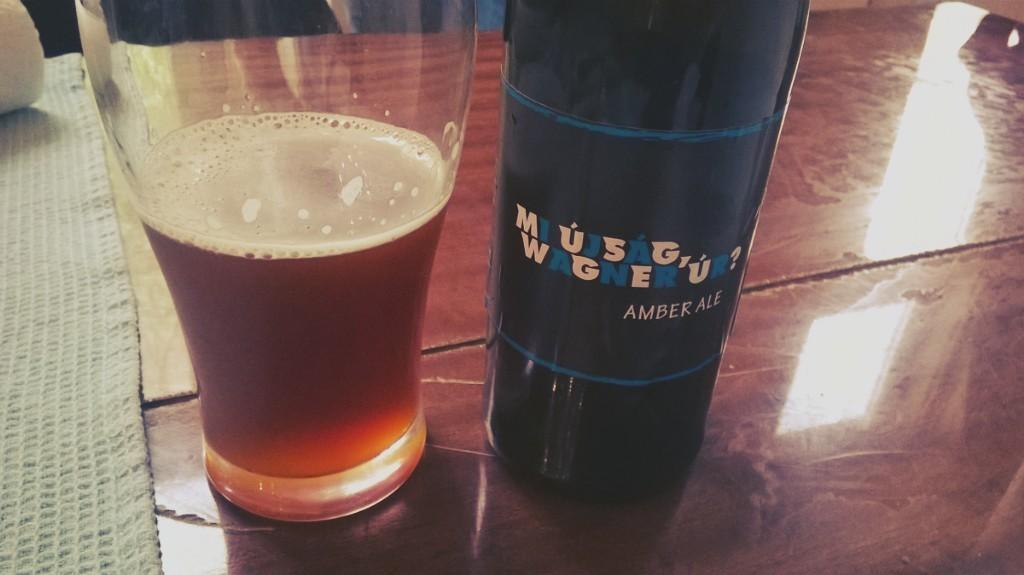<image>
Render a clear and concise summary of the photo. An amber ale in a black bottle is on a wooden table to next to a glass with the ale in it. 